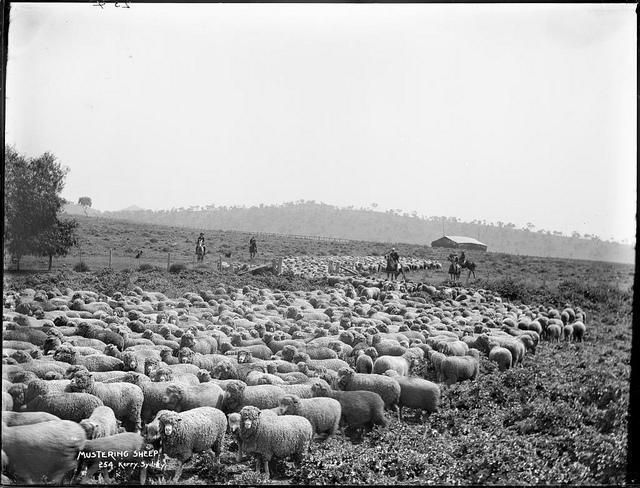How many sheep can be seen?
Give a very brief answer. 4. How many toilet covers are there?
Give a very brief answer. 0. 